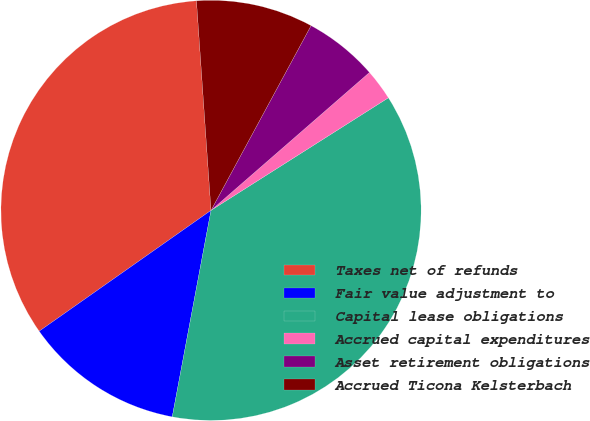<chart> <loc_0><loc_0><loc_500><loc_500><pie_chart><fcel>Taxes net of refunds<fcel>Fair value adjustment to<fcel>Capital lease obligations<fcel>Accrued capital expenditures<fcel>Asset retirement obligations<fcel>Accrued Ticona Kelsterbach<nl><fcel>33.65%<fcel>12.29%<fcel>36.95%<fcel>2.4%<fcel>5.7%<fcel>9.0%<nl></chart> 